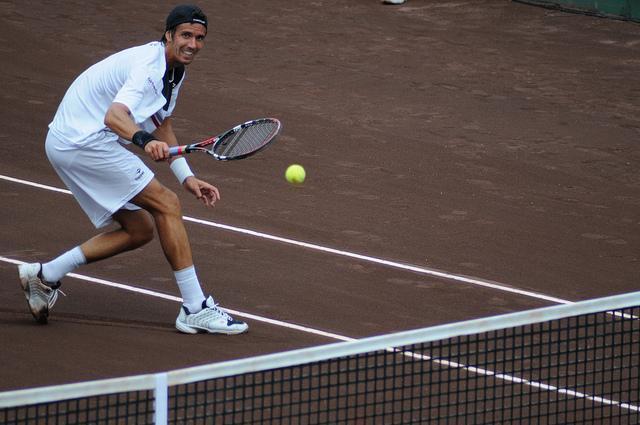How is the tennis player feeling?
Pick the right solution, then justify: 'Answer: answer
Rationale: rationale.'
Options: Tired, angry, sad, happy. Answer: happy.
Rationale: The person is happy. 